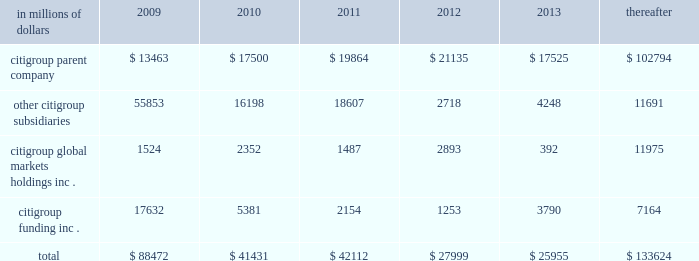Cgmhi also has substantial borrowing arrangements consisting of facilities that cgmhi has been advised are available , but where no contractual lending obligation exists .
These arrangements are reviewed on an ongoing basis to ensure flexibility in meeting cgmhi 2019s short-term requirements .
The company issues both fixed and variable rate debt in a range of currencies .
It uses derivative contracts , primarily interest rate swaps , to effectively convert a portion of its fixed rate debt to variable rate debt and variable rate debt to fixed rate debt .
The maturity structure of the derivatives generally corresponds to the maturity structure of the debt being hedged .
In addition , the company uses other derivative contracts to manage the foreign exchange impact of certain debt issuances .
At december 31 , 2008 , the company 2019s overall weighted average interest rate for long-term debt was 3.83% ( 3.83 % ) on a contractual basis and 4.19% ( 4.19 % ) including the effects of derivative contracts .
Aggregate annual maturities of long-term debt obligations ( based on final maturity dates ) including trust preferred securities are as follows : in millions of dollars 2009 2010 2011 2012 2013 thereafter .
Long-term debt at december 31 , 2008 and december 31 , 2007 includes $ 24060 million and $ 23756 million , respectively , of junior subordinated debt .
The company formed statutory business trusts under the laws of the state of delaware .
The trusts exist for the exclusive purposes of ( i ) issuing trust securities representing undivided beneficial interests in the assets of the trust ; ( ii ) investing the gross proceeds of the trust securities in junior subordinated deferrable interest debentures ( subordinated debentures ) of its parent ; and ( iii ) engaging in only those activities necessary or incidental thereto .
Upon approval from the federal reserve , citigroup has the right to redeem these securities .
Citigroup has contractually agreed not to redeem or purchase ( i ) the 6.50% ( 6.50 % ) enhanced trust preferred securities of citigroup capital xv before september 15 , 2056 , ( ii ) the 6.45% ( 6.45 % ) enhanced trust preferred securities of citigroup capital xvi before december 31 , 2046 , ( iii ) the 6.35% ( 6.35 % ) enhanced trust preferred securities of citigroup capital xvii before march 15 , 2057 , ( iv ) the 6.829% ( 6.829 % ) fixed rate/floating rate enhanced trust preferred securities of citigroup capital xviii before june 28 , 2047 , ( v ) the 7.250% ( 7.250 % ) enhanced trust preferred securities of citigroup capital xix before august 15 , 2047 , ( vi ) the 7.875% ( 7.875 % ) enhanced trust preferred securities of citigroup capital xx before december 15 , 2067 , and ( vii ) the 8.300% ( 8.300 % ) fixed rate/floating rate enhanced trust preferred securities of citigroup capital xxi before december 21 , 2067 unless certain conditions , described in exhibit 4.03 to citigroup 2019s current report on form 8-k filed on september 18 , 2006 , in exhibit 4.02 to citigroup 2019s current report on form 8-k filed on november 28 , 2006 , in exhibit 4.02 to citigroup 2019s current report on form 8-k filed on march 8 , 2007 , in exhibit 4.02 to citigroup 2019s current report on form 8-k filed on july 2 , 2007 , in exhibit 4.02 to citigroup 2019s current report on form 8-k filed on august 17 , 2007 , in exhibit 4.2 to citigroup 2019s current report on form 8-k filed on november 27 , 2007 , and in exhibit 4.2 to citigroup 2019s current report on form 8-k filed on december 21 , 2007 , respectively , are met .
These agreements are for the benefit of the holders of citigroup 2019s 6.00% ( 6.00 % ) junior subordinated deferrable interest debentures due 2034 .
Citigroup owns all of the voting securities of these subsidiary trusts .
These subsidiary trusts have no assets , operations , revenues or cash flows other than those related to the issuance , administration and repayment of the subsidiary trusts and the subsidiary trusts 2019 common securities .
These subsidiary trusts 2019 obligations are fully and unconditionally guaranteed by citigroup. .
What percentage of total aggregate annual maturities of long-term debt obligations ( based on final maturity dates ) including trust preferred securities due in 2009 are related to citigroup funding inc . ? 
Computations: (17632 / 88472)
Answer: 0.19929. 